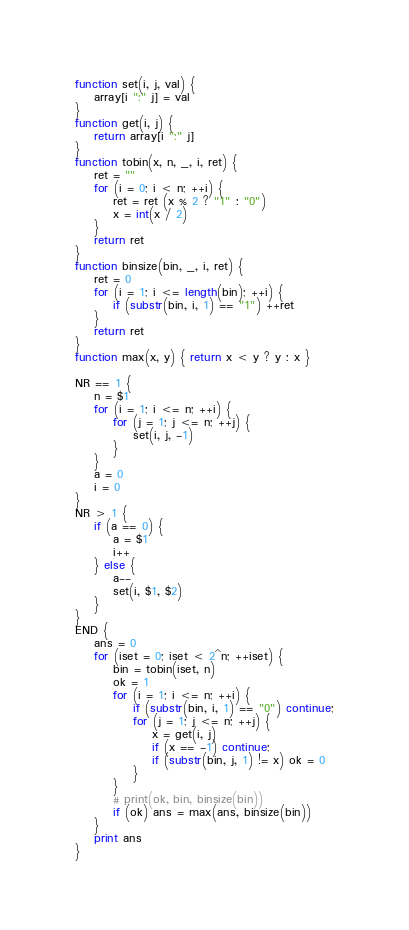<code> <loc_0><loc_0><loc_500><loc_500><_Awk_>function set(i, j, val) {
    array[i ":" j] = val
}
function get(i, j) {
    return array[i ":" j]
}
function tobin(x, n, _, i, ret) {
    ret = ""
    for (i = 0; i < n; ++i) {
        ret = ret (x % 2 ? "1" : "0")
        x = int(x / 2)
    }
    return ret
}
function binsize(bin, _, i, ret) {
    ret = 0
    for (i = 1; i <= length(bin); ++i) {
        if (substr(bin, i, 1) == "1") ++ret
    }
    return ret
}
function max(x, y) { return x < y ? y : x }

NR == 1 {
    n = $1
    for (i = 1; i <= n; ++i) {
        for (j = 1; j <= n; ++j) {
            set(i, j, -1)
        }
    }
    a = 0
    i = 0
}
NR > 1 {
    if (a == 0) {
        a = $1
        i++
    } else {
        a--
        set(i, $1, $2)
    }
}
END {
    ans = 0
    for (iset = 0; iset < 2^n; ++iset) {
        bin = tobin(iset, n)
        ok = 1
        for (i = 1; i <= n; ++i) {
            if (substr(bin, i, 1) == "0") continue;
            for (j = 1; j <= n; ++j) {
                x = get(i, j)
                if (x == -1) continue;
                if (substr(bin, j, 1) != x) ok = 0
            }
        }
        # print(ok, bin, binsize(bin))
        if (ok) ans = max(ans, binsize(bin))
    }
    print ans
}
</code> 